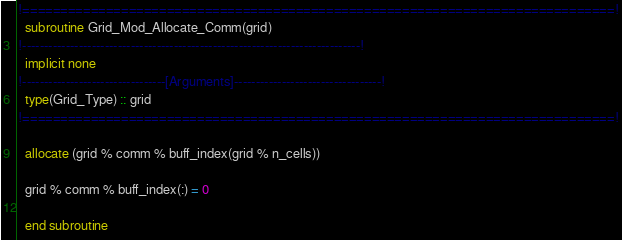Convert code to text. <code><loc_0><loc_0><loc_500><loc_500><_FORTRAN_>!==============================================================================!
  subroutine Grid_Mod_Allocate_Comm(grid)
!------------------------------------------------------------------------------!
  implicit none
!---------------------------------[Arguments]----------------------------------!
  type(Grid_Type) :: grid
!==============================================================================!

  allocate (grid % comm % buff_index(grid % n_cells))

  grid % comm % buff_index(:) = 0

  end subroutine
</code> 